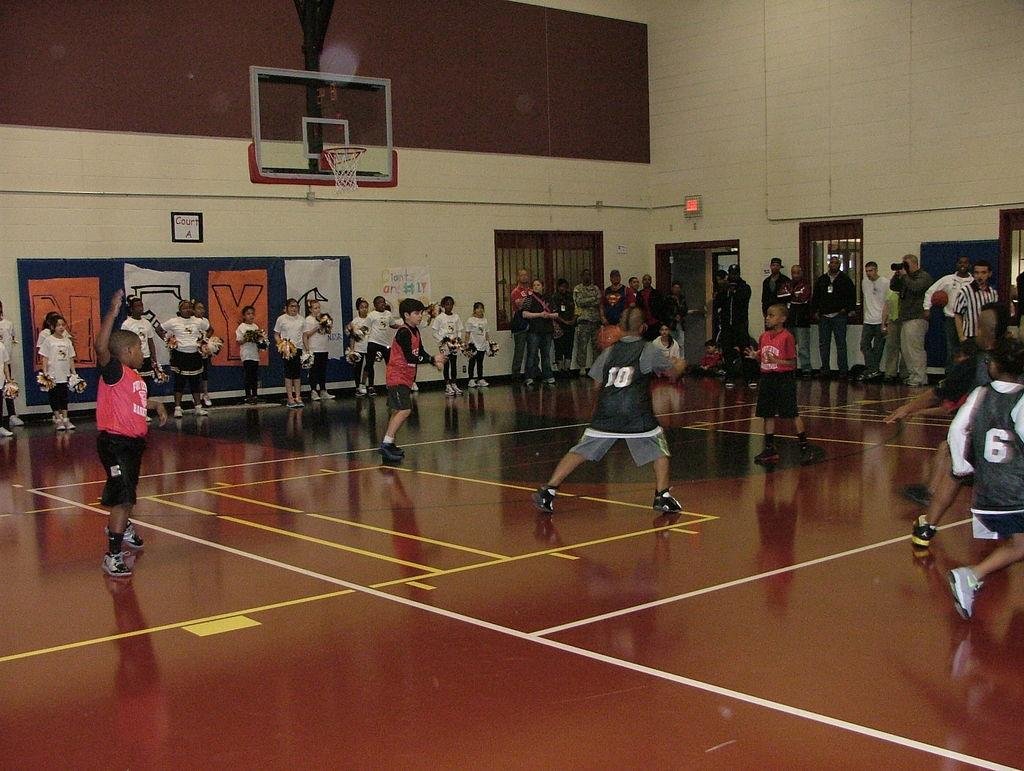<image>
Describe the image concisely. Player number 10 dribbles a ball during a basketball game. 